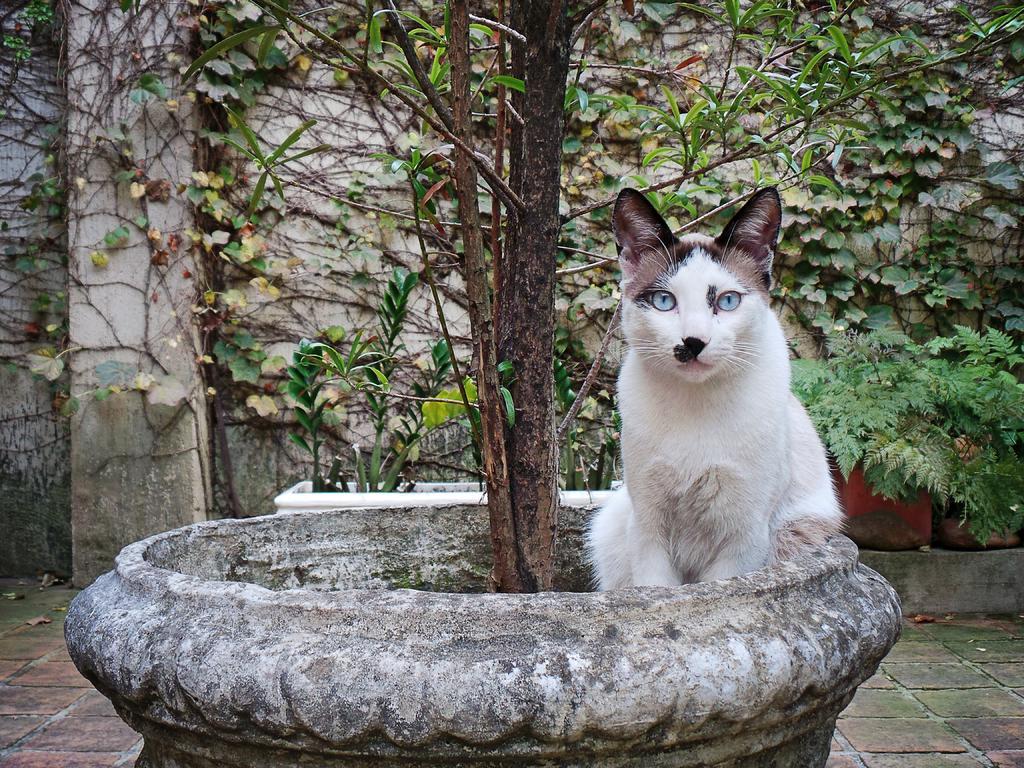Describe this image in one or two sentences. In this picture we can see a cat, pots, plants, leaves on the ground and in the background we can see the wall. 